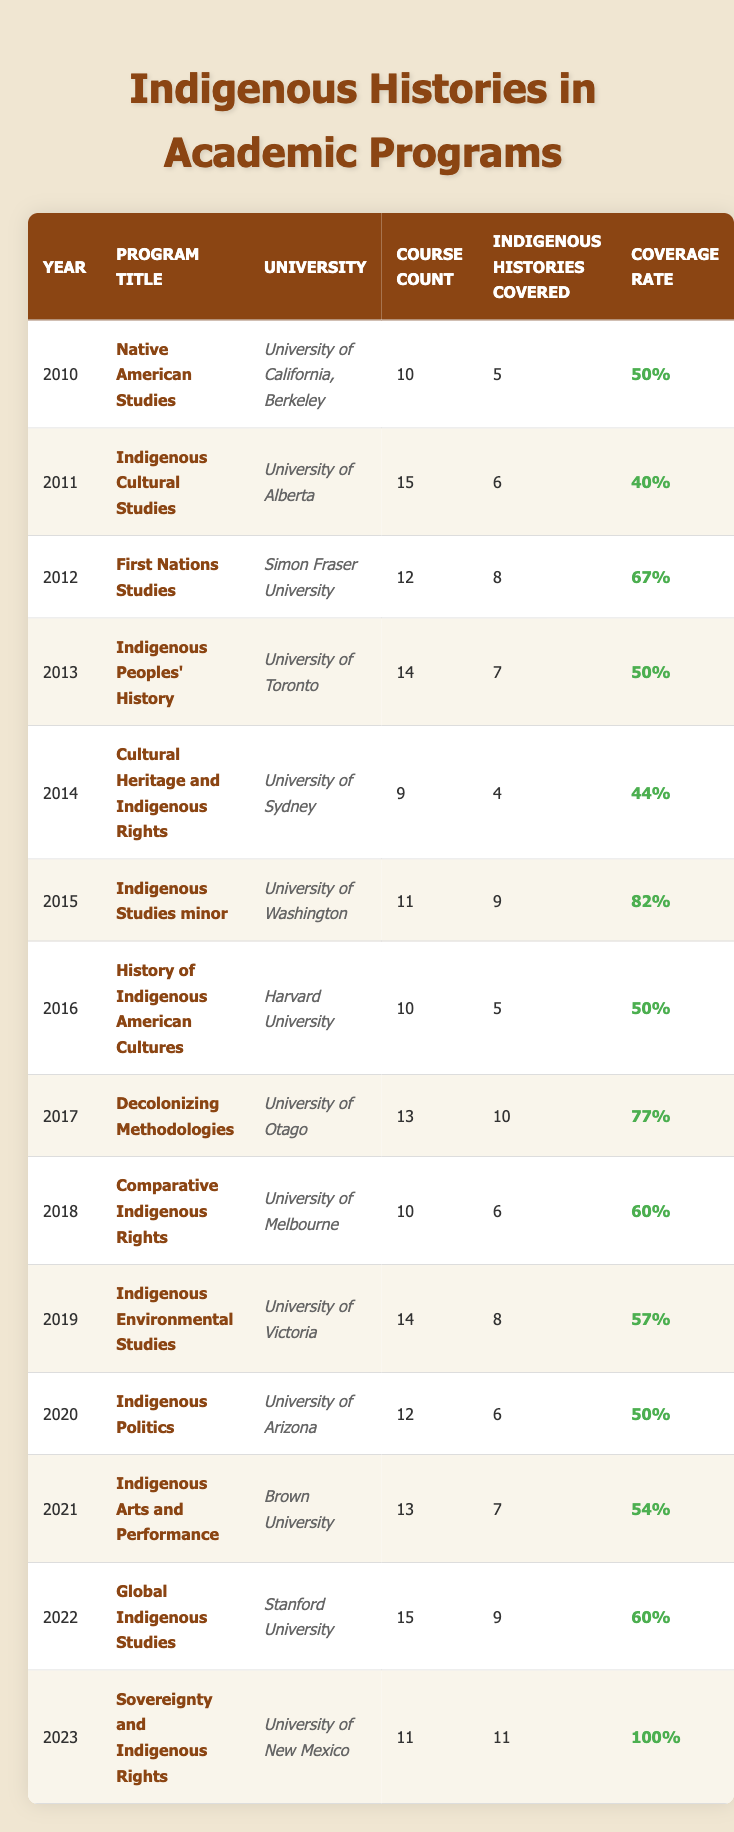What program in 2023 covered the most indigenous histories? In 2023, the program titled "Sovereignty and Indigenous Rights" at the University of New Mexico covered 11 indigenous histories, which is the highest number in that year compared to all other years listed.
Answer: Sovereignty and Indigenous Rights Which year had the highest percentage of indigenous histories coverage? In 2023, "Sovereignty and Indigenous Rights" covered 11 out of 11 courses, resulting in a 100% coverage rate, which is the highest in the table.
Answer: 2023 How many indigenous histories were covered in the University of California, Berkeley by 2010? In 2010, the program "Native American Studies" at the University of California, Berkeley covered 5 indigenous histories out of 10 courses.
Answer: 5 What was the average number of indigenous histories covered from 2010 to 2022? Summing the indigenous histories covered from 2010 (5), 2011 (6), 2012 (8), 2013 (7), 2014 (4), 2015 (9), 2016 (5), 2017 (10), 2018 (6), 2019 (8), 2020 (6), 2021 (7), 2022 (9) gives a total of 66. There are 13 years (2010-2022), so the average is 66 / 13 = 5.08 (approximately 5).
Answer: 5 Did the coverage rate improve from 2015 to 2023? In 2015, the coverage rate was 82%, while in 2023 it was 100%. This indicates that the rate improved over those years.
Answer: Yes Which university had the highest course count in 2011, and how many indigenous histories were covered? In 2011, the University of Alberta offered "Indigenous Cultural Studies" with a course count of 15, covering 6 indigenous histories.
Answer: University of Alberta, 6 What is the difference in indigenous histories covered between 2012 and 2019? In 2012, 8 indigenous histories were covered, while in 2019, 8 were also covered. Therefore, the difference is 8 - 8 = 0.
Answer: 0 For which program was there a drop in the coverage rate from the previous year, and what was the difference in the rates? From 2017 (77%) to 2018 (60%), the program "Comparative Indigenous Rights" saw a drop of 17%.
Answer: Comparative Indigenous Rights, 17% 